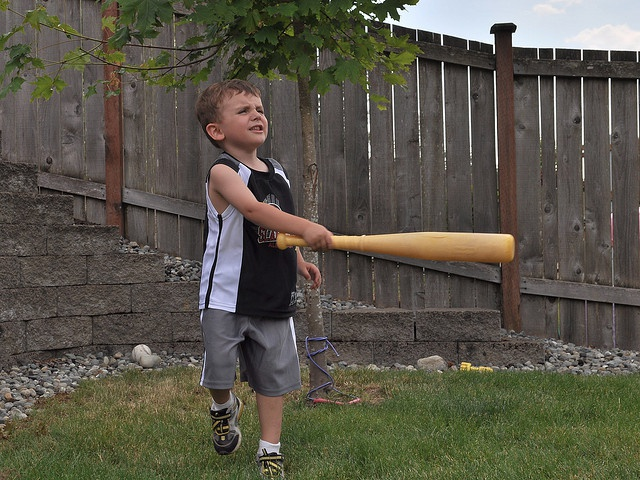Describe the objects in this image and their specific colors. I can see people in darkgreen, black, gray, brown, and darkgray tones, baseball bat in darkgreen, tan, brown, and maroon tones, and sports ball in darkgreen, darkgray, gray, and lightgray tones in this image. 